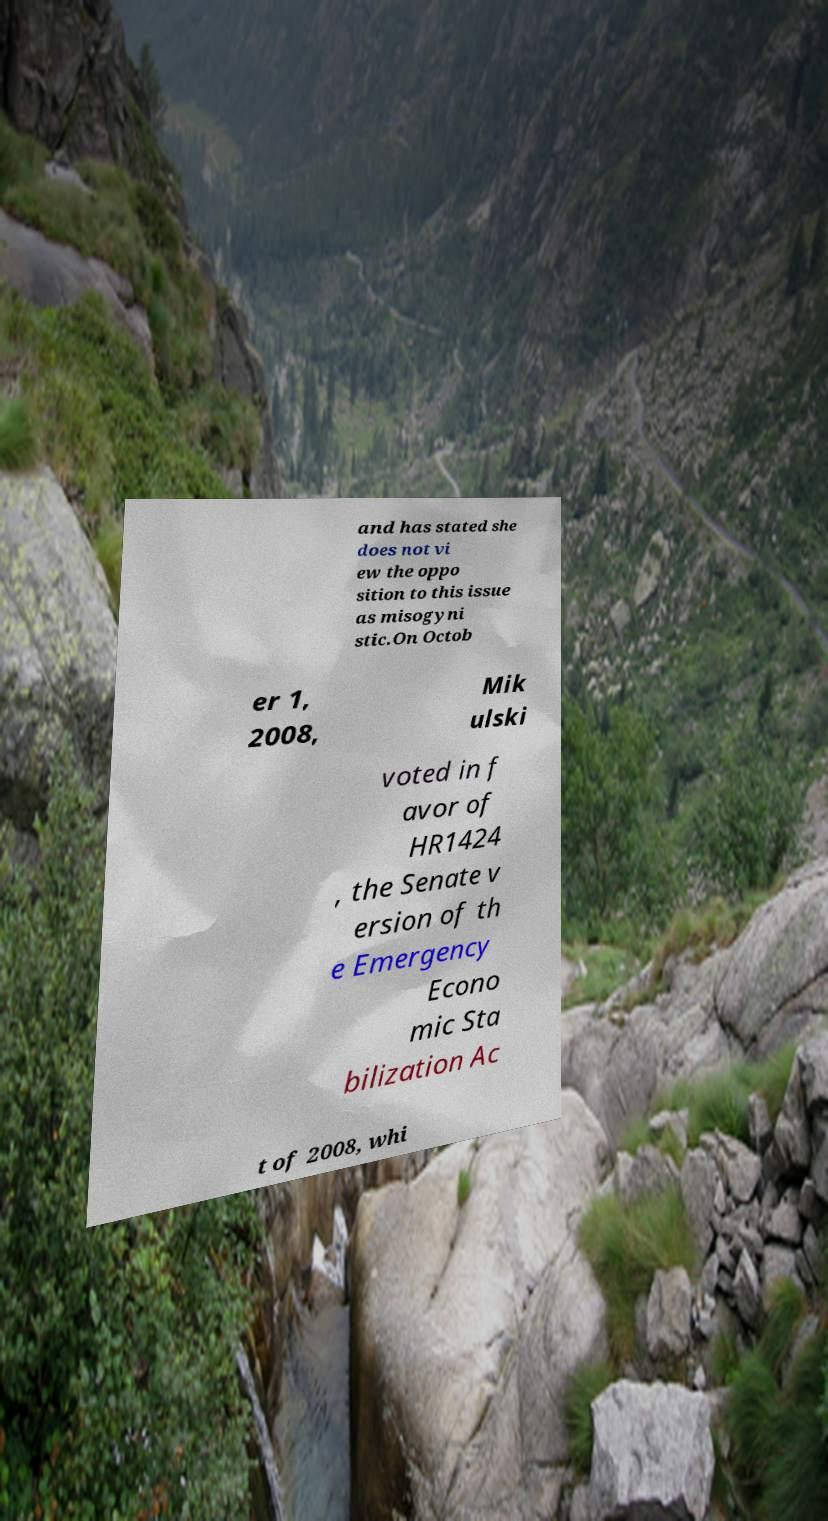I need the written content from this picture converted into text. Can you do that? and has stated she does not vi ew the oppo sition to this issue as misogyni stic.On Octob er 1, 2008, Mik ulski voted in f avor of HR1424 , the Senate v ersion of th e Emergency Econo mic Sta bilization Ac t of 2008, whi 